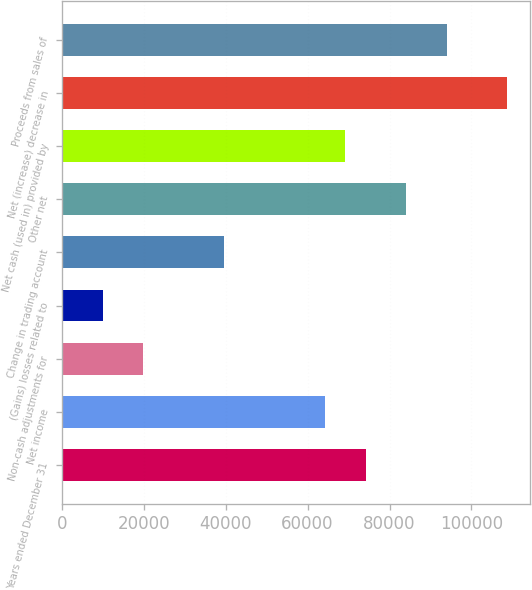Convert chart. <chart><loc_0><loc_0><loc_500><loc_500><bar_chart><fcel>Years ended December 31<fcel>Net income<fcel>Non-cash adjustments for<fcel>(Gains) losses related to<fcel>Change in trading account<fcel>Other net<fcel>Net cash (used in) provided by<fcel>Net (increase) decrease in<fcel>Proceeds from sales of<nl><fcel>74171<fcel>64287.4<fcel>19811.2<fcel>9927.6<fcel>39578.4<fcel>84054.6<fcel>69229.2<fcel>108764<fcel>93938.2<nl></chart> 